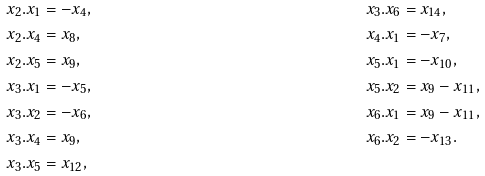Convert formula to latex. <formula><loc_0><loc_0><loc_500><loc_500>x _ { 2 } . x _ { 1 } & = - x _ { 4 } , & & x _ { 3 } . x _ { 6 } = x _ { 1 4 } , \\ x _ { 2 } . x _ { 4 } & = x _ { 8 } , & & x _ { 4 } . x _ { 1 } = - x _ { 7 } , \\ x _ { 2 } . x _ { 5 } & = x _ { 9 } , & & x _ { 5 } . x _ { 1 } = - x _ { 1 0 } , \\ x _ { 3 } . x _ { 1 } & = - x _ { 5 } , & & x _ { 5 } . x _ { 2 } = x _ { 9 } - x _ { 1 1 } , \\ x _ { 3 } . x _ { 2 } & = - x _ { 6 } , & & x _ { 6 } . x _ { 1 } = x _ { 9 } - x _ { 1 1 } , \\ x _ { 3 } . x _ { 4 } & = x _ { 9 } , & & x _ { 6 } . x _ { 2 } = - x _ { 1 3 } . \\ x _ { 3 } . x _ { 5 } & = x _ { 1 2 } ,</formula> 